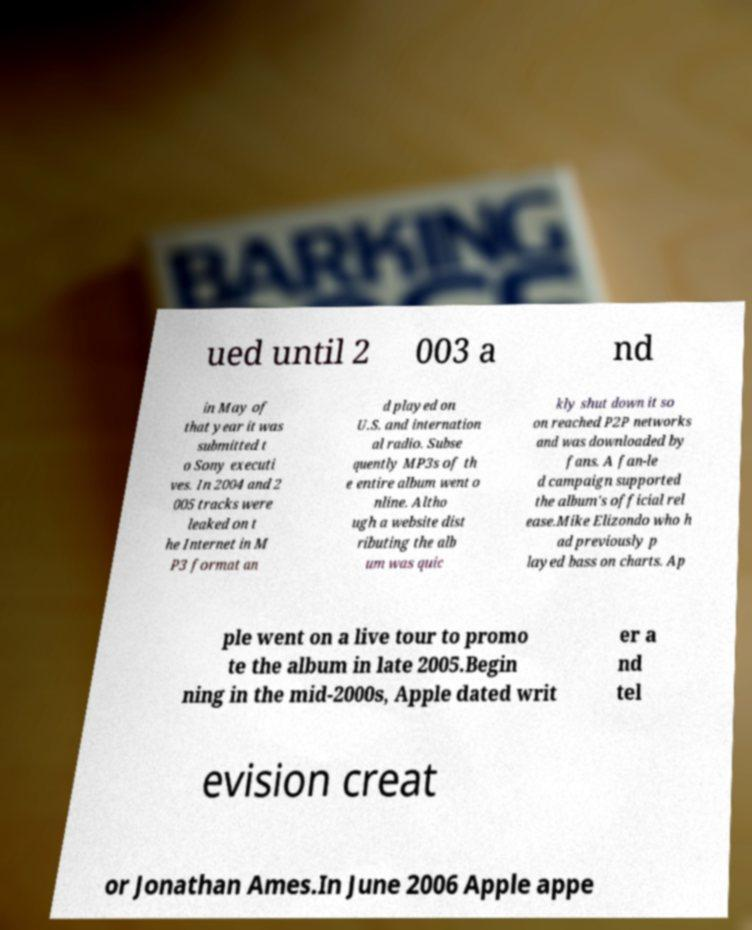What messages or text are displayed in this image? I need them in a readable, typed format. ued until 2 003 a nd in May of that year it was submitted t o Sony executi ves. In 2004 and 2 005 tracks were leaked on t he Internet in M P3 format an d played on U.S. and internation al radio. Subse quently MP3s of th e entire album went o nline. Altho ugh a website dist ributing the alb um was quic kly shut down it so on reached P2P networks and was downloaded by fans. A fan-le d campaign supported the album's official rel ease.Mike Elizondo who h ad previously p layed bass on charts. Ap ple went on a live tour to promo te the album in late 2005.Begin ning in the mid-2000s, Apple dated writ er a nd tel evision creat or Jonathan Ames.In June 2006 Apple appe 